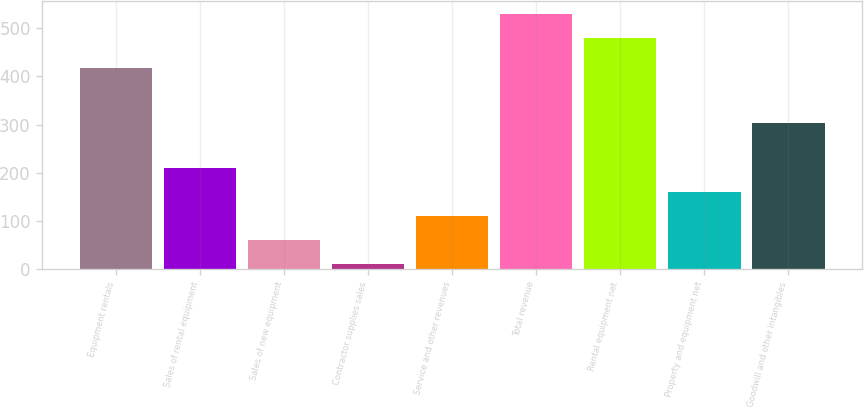Convert chart to OTSL. <chart><loc_0><loc_0><loc_500><loc_500><bar_chart><fcel>Equipment rentals<fcel>Sales of rental equipment<fcel>Sales of new equipment<fcel>Contractor supplies sales<fcel>Service and other revenues<fcel>Total revenue<fcel>Rental equipment net<fcel>Property and equipment net<fcel>Goodwill and other intangibles<nl><fcel>417<fcel>210.6<fcel>60.9<fcel>11<fcel>110.8<fcel>529.9<fcel>480<fcel>160.7<fcel>303<nl></chart> 